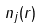Convert formula to latex. <formula><loc_0><loc_0><loc_500><loc_500>n _ { j } ( r )</formula> 